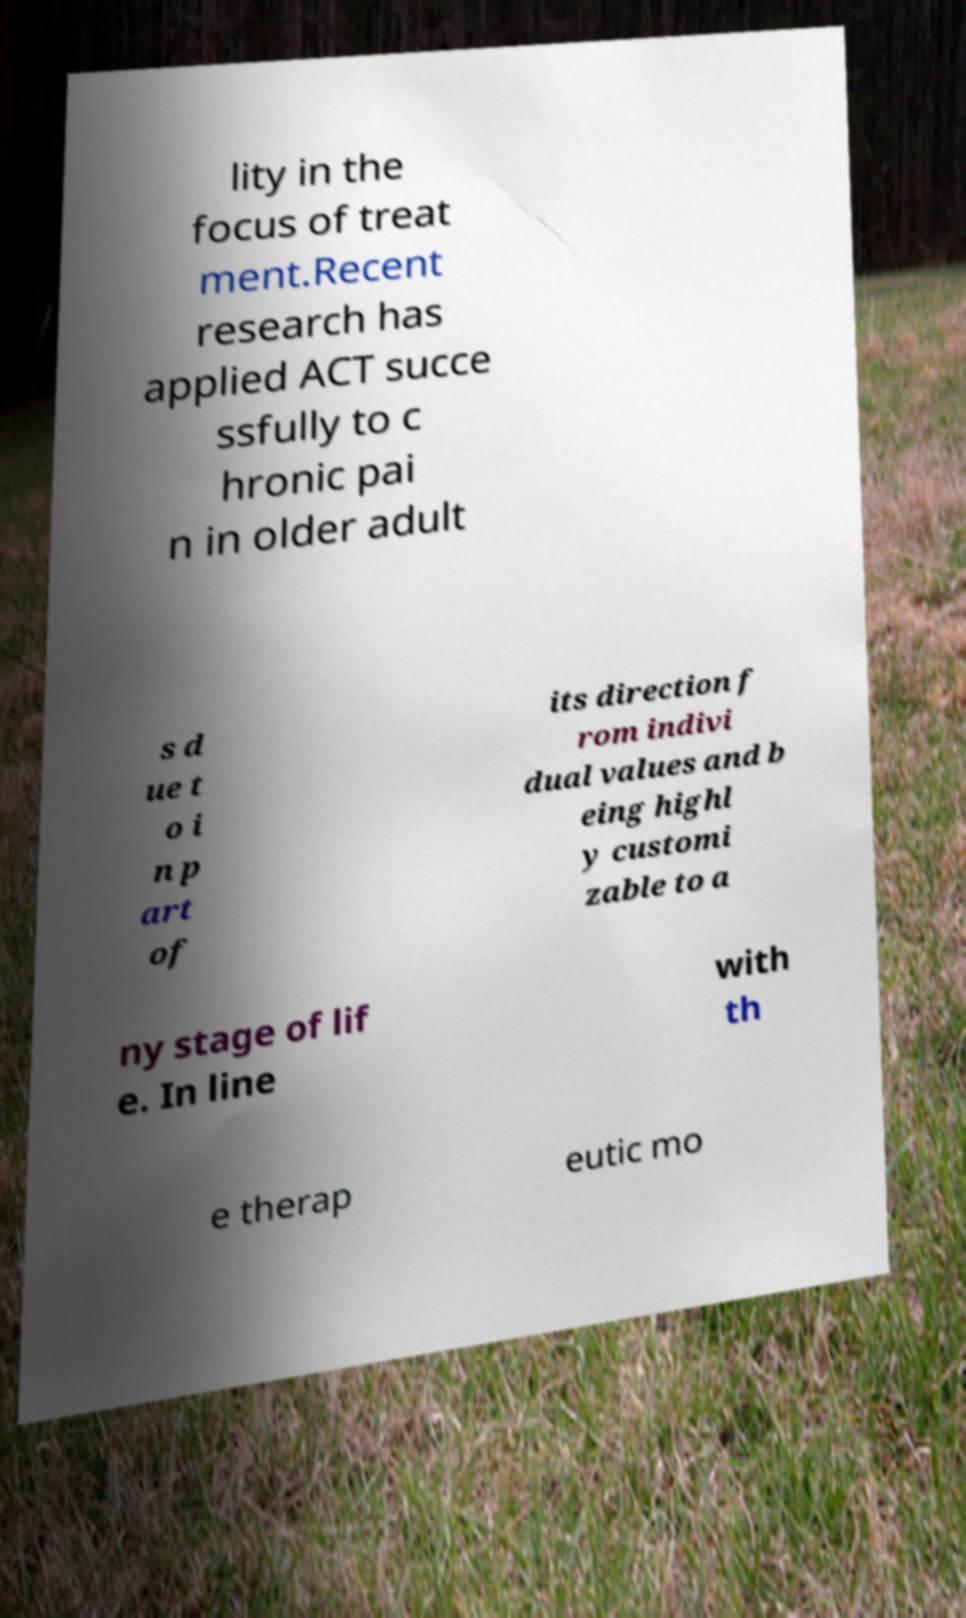I need the written content from this picture converted into text. Can you do that? lity in the focus of treat ment.Recent research has applied ACT succe ssfully to c hronic pai n in older adult s d ue t o i n p art of its direction f rom indivi dual values and b eing highl y customi zable to a ny stage of lif e. In line with th e therap eutic mo 